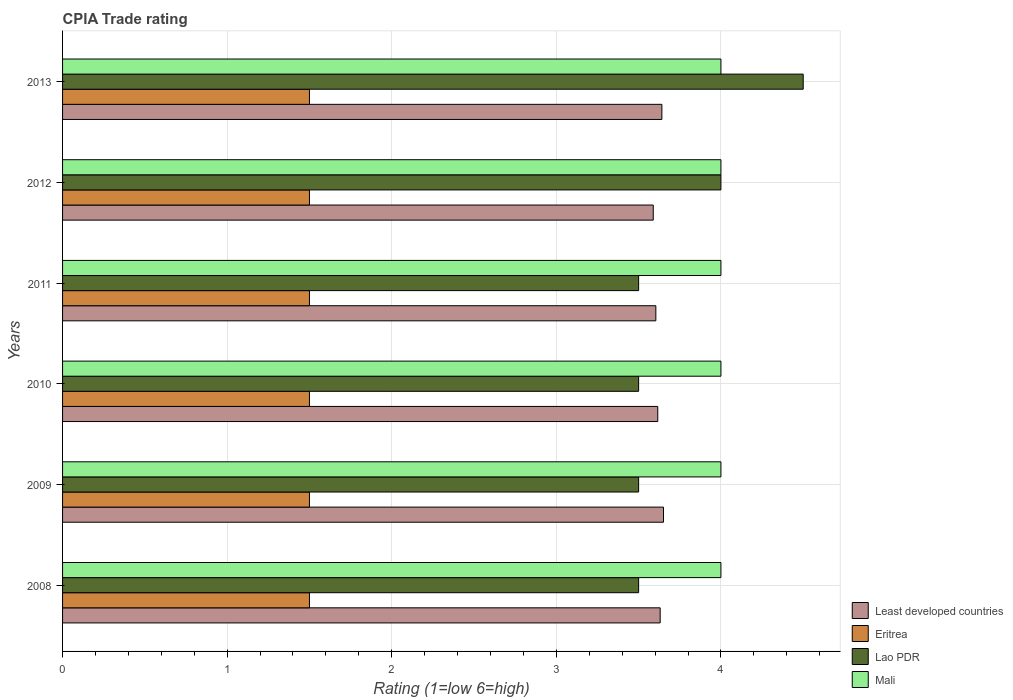How many different coloured bars are there?
Ensure brevity in your answer.  4. How many bars are there on the 1st tick from the top?
Ensure brevity in your answer.  4. How many bars are there on the 5th tick from the bottom?
Provide a succinct answer. 4. What is the label of the 4th group of bars from the top?
Your answer should be compact. 2010. In how many cases, is the number of bars for a given year not equal to the number of legend labels?
Your answer should be very brief. 0. What is the CPIA rating in Lao PDR in 2010?
Make the answer very short. 3.5. Across all years, what is the maximum CPIA rating in Least developed countries?
Give a very brief answer. 3.65. Across all years, what is the minimum CPIA rating in Mali?
Offer a terse response. 4. In which year was the CPIA rating in Least developed countries maximum?
Offer a terse response. 2009. In which year was the CPIA rating in Mali minimum?
Make the answer very short. 2008. What is the total CPIA rating in Lao PDR in the graph?
Your answer should be compact. 22.5. What is the difference between the CPIA rating in Mali in 2008 and the CPIA rating in Least developed countries in 2013?
Offer a terse response. 0.36. In the year 2013, what is the difference between the CPIA rating in Mali and CPIA rating in Eritrea?
Your answer should be compact. 2.5. What is the ratio of the CPIA rating in Mali in 2010 to that in 2012?
Make the answer very short. 1. Is the difference between the CPIA rating in Mali in 2010 and 2012 greater than the difference between the CPIA rating in Eritrea in 2010 and 2012?
Offer a terse response. No. What is the difference between the highest and the second highest CPIA rating in Mali?
Provide a short and direct response. 0. What is the difference between the highest and the lowest CPIA rating in Least developed countries?
Your answer should be compact. 0.06. What does the 1st bar from the top in 2009 represents?
Ensure brevity in your answer.  Mali. What does the 2nd bar from the bottom in 2010 represents?
Give a very brief answer. Eritrea. Is it the case that in every year, the sum of the CPIA rating in Mali and CPIA rating in Least developed countries is greater than the CPIA rating in Lao PDR?
Keep it short and to the point. Yes. Are the values on the major ticks of X-axis written in scientific E-notation?
Offer a terse response. No. Does the graph contain grids?
Keep it short and to the point. Yes. Where does the legend appear in the graph?
Your answer should be very brief. Bottom right. How many legend labels are there?
Give a very brief answer. 4. How are the legend labels stacked?
Your answer should be very brief. Vertical. What is the title of the graph?
Provide a succinct answer. CPIA Trade rating. What is the label or title of the Y-axis?
Your answer should be compact. Years. What is the Rating (1=low 6=high) of Least developed countries in 2008?
Offer a very short reply. 3.63. What is the Rating (1=low 6=high) of Eritrea in 2008?
Make the answer very short. 1.5. What is the Rating (1=low 6=high) of Least developed countries in 2009?
Give a very brief answer. 3.65. What is the Rating (1=low 6=high) of Lao PDR in 2009?
Provide a short and direct response. 3.5. What is the Rating (1=low 6=high) of Mali in 2009?
Your answer should be compact. 4. What is the Rating (1=low 6=high) in Least developed countries in 2010?
Provide a short and direct response. 3.62. What is the Rating (1=low 6=high) of Eritrea in 2010?
Give a very brief answer. 1.5. What is the Rating (1=low 6=high) of Mali in 2010?
Your answer should be compact. 4. What is the Rating (1=low 6=high) in Least developed countries in 2011?
Provide a short and direct response. 3.6. What is the Rating (1=low 6=high) in Eritrea in 2011?
Your answer should be compact. 1.5. What is the Rating (1=low 6=high) of Lao PDR in 2011?
Offer a terse response. 3.5. What is the Rating (1=low 6=high) in Mali in 2011?
Provide a succinct answer. 4. What is the Rating (1=low 6=high) of Least developed countries in 2012?
Provide a succinct answer. 3.59. What is the Rating (1=low 6=high) in Lao PDR in 2012?
Your answer should be very brief. 4. What is the Rating (1=low 6=high) of Least developed countries in 2013?
Keep it short and to the point. 3.64. What is the Rating (1=low 6=high) of Mali in 2013?
Your answer should be compact. 4. Across all years, what is the maximum Rating (1=low 6=high) in Least developed countries?
Offer a very short reply. 3.65. Across all years, what is the maximum Rating (1=low 6=high) in Eritrea?
Give a very brief answer. 1.5. Across all years, what is the minimum Rating (1=low 6=high) of Least developed countries?
Your answer should be very brief. 3.59. Across all years, what is the minimum Rating (1=low 6=high) of Lao PDR?
Keep it short and to the point. 3.5. Across all years, what is the minimum Rating (1=low 6=high) in Mali?
Ensure brevity in your answer.  4. What is the total Rating (1=low 6=high) in Least developed countries in the graph?
Provide a short and direct response. 21.73. What is the total Rating (1=low 6=high) of Mali in the graph?
Your answer should be very brief. 24. What is the difference between the Rating (1=low 6=high) in Least developed countries in 2008 and that in 2009?
Offer a terse response. -0.02. What is the difference between the Rating (1=low 6=high) in Eritrea in 2008 and that in 2009?
Your answer should be compact. 0. What is the difference between the Rating (1=low 6=high) of Mali in 2008 and that in 2009?
Provide a succinct answer. 0. What is the difference between the Rating (1=low 6=high) in Least developed countries in 2008 and that in 2010?
Your answer should be compact. 0.01. What is the difference between the Rating (1=low 6=high) of Eritrea in 2008 and that in 2010?
Your response must be concise. 0. What is the difference between the Rating (1=low 6=high) in Least developed countries in 2008 and that in 2011?
Provide a succinct answer. 0.03. What is the difference between the Rating (1=low 6=high) in Lao PDR in 2008 and that in 2011?
Make the answer very short. 0. What is the difference between the Rating (1=low 6=high) in Mali in 2008 and that in 2011?
Keep it short and to the point. 0. What is the difference between the Rating (1=low 6=high) of Least developed countries in 2008 and that in 2012?
Your response must be concise. 0.04. What is the difference between the Rating (1=low 6=high) in Least developed countries in 2008 and that in 2013?
Ensure brevity in your answer.  -0.01. What is the difference between the Rating (1=low 6=high) of Lao PDR in 2008 and that in 2013?
Provide a succinct answer. -1. What is the difference between the Rating (1=low 6=high) in Mali in 2008 and that in 2013?
Ensure brevity in your answer.  0. What is the difference between the Rating (1=low 6=high) in Least developed countries in 2009 and that in 2010?
Provide a succinct answer. 0.03. What is the difference between the Rating (1=low 6=high) in Eritrea in 2009 and that in 2010?
Make the answer very short. 0. What is the difference between the Rating (1=low 6=high) in Mali in 2009 and that in 2010?
Offer a very short reply. 0. What is the difference between the Rating (1=low 6=high) in Least developed countries in 2009 and that in 2011?
Make the answer very short. 0.05. What is the difference between the Rating (1=low 6=high) of Eritrea in 2009 and that in 2011?
Your answer should be very brief. 0. What is the difference between the Rating (1=low 6=high) of Lao PDR in 2009 and that in 2011?
Your answer should be very brief. 0. What is the difference between the Rating (1=low 6=high) in Mali in 2009 and that in 2011?
Give a very brief answer. 0. What is the difference between the Rating (1=low 6=high) in Least developed countries in 2009 and that in 2012?
Ensure brevity in your answer.  0.06. What is the difference between the Rating (1=low 6=high) of Lao PDR in 2009 and that in 2012?
Your answer should be very brief. -0.5. What is the difference between the Rating (1=low 6=high) in Mali in 2009 and that in 2012?
Your answer should be very brief. 0. What is the difference between the Rating (1=low 6=high) of Least developed countries in 2009 and that in 2013?
Provide a succinct answer. 0.01. What is the difference between the Rating (1=low 6=high) of Eritrea in 2009 and that in 2013?
Provide a short and direct response. 0. What is the difference between the Rating (1=low 6=high) in Lao PDR in 2009 and that in 2013?
Keep it short and to the point. -1. What is the difference between the Rating (1=low 6=high) in Mali in 2009 and that in 2013?
Provide a succinct answer. 0. What is the difference between the Rating (1=low 6=high) of Least developed countries in 2010 and that in 2011?
Make the answer very short. 0.01. What is the difference between the Rating (1=low 6=high) of Lao PDR in 2010 and that in 2011?
Keep it short and to the point. 0. What is the difference between the Rating (1=low 6=high) in Least developed countries in 2010 and that in 2012?
Your answer should be compact. 0.03. What is the difference between the Rating (1=low 6=high) in Lao PDR in 2010 and that in 2012?
Ensure brevity in your answer.  -0.5. What is the difference between the Rating (1=low 6=high) of Mali in 2010 and that in 2012?
Offer a terse response. 0. What is the difference between the Rating (1=low 6=high) in Least developed countries in 2010 and that in 2013?
Offer a very short reply. -0.03. What is the difference between the Rating (1=low 6=high) of Eritrea in 2010 and that in 2013?
Offer a terse response. 0. What is the difference between the Rating (1=low 6=high) of Lao PDR in 2010 and that in 2013?
Provide a succinct answer. -1. What is the difference between the Rating (1=low 6=high) in Mali in 2010 and that in 2013?
Provide a short and direct response. 0. What is the difference between the Rating (1=low 6=high) of Least developed countries in 2011 and that in 2012?
Make the answer very short. 0.02. What is the difference between the Rating (1=low 6=high) of Eritrea in 2011 and that in 2012?
Provide a short and direct response. 0. What is the difference between the Rating (1=low 6=high) of Lao PDR in 2011 and that in 2012?
Make the answer very short. -0.5. What is the difference between the Rating (1=low 6=high) in Mali in 2011 and that in 2012?
Offer a terse response. 0. What is the difference between the Rating (1=low 6=high) in Least developed countries in 2011 and that in 2013?
Your answer should be compact. -0.04. What is the difference between the Rating (1=low 6=high) in Eritrea in 2011 and that in 2013?
Your answer should be compact. 0. What is the difference between the Rating (1=low 6=high) in Mali in 2011 and that in 2013?
Make the answer very short. 0. What is the difference between the Rating (1=low 6=high) in Least developed countries in 2012 and that in 2013?
Give a very brief answer. -0.05. What is the difference between the Rating (1=low 6=high) in Least developed countries in 2008 and the Rating (1=low 6=high) in Eritrea in 2009?
Keep it short and to the point. 2.13. What is the difference between the Rating (1=low 6=high) in Least developed countries in 2008 and the Rating (1=low 6=high) in Lao PDR in 2009?
Your response must be concise. 0.13. What is the difference between the Rating (1=low 6=high) in Least developed countries in 2008 and the Rating (1=low 6=high) in Mali in 2009?
Provide a succinct answer. -0.37. What is the difference between the Rating (1=low 6=high) in Eritrea in 2008 and the Rating (1=low 6=high) in Lao PDR in 2009?
Make the answer very short. -2. What is the difference between the Rating (1=low 6=high) in Lao PDR in 2008 and the Rating (1=low 6=high) in Mali in 2009?
Give a very brief answer. -0.5. What is the difference between the Rating (1=low 6=high) of Least developed countries in 2008 and the Rating (1=low 6=high) of Eritrea in 2010?
Your response must be concise. 2.13. What is the difference between the Rating (1=low 6=high) of Least developed countries in 2008 and the Rating (1=low 6=high) of Lao PDR in 2010?
Your response must be concise. 0.13. What is the difference between the Rating (1=low 6=high) of Least developed countries in 2008 and the Rating (1=low 6=high) of Mali in 2010?
Offer a very short reply. -0.37. What is the difference between the Rating (1=low 6=high) in Eritrea in 2008 and the Rating (1=low 6=high) in Lao PDR in 2010?
Make the answer very short. -2. What is the difference between the Rating (1=low 6=high) of Eritrea in 2008 and the Rating (1=low 6=high) of Mali in 2010?
Offer a terse response. -2.5. What is the difference between the Rating (1=low 6=high) in Lao PDR in 2008 and the Rating (1=low 6=high) in Mali in 2010?
Offer a very short reply. -0.5. What is the difference between the Rating (1=low 6=high) of Least developed countries in 2008 and the Rating (1=low 6=high) of Eritrea in 2011?
Offer a very short reply. 2.13. What is the difference between the Rating (1=low 6=high) of Least developed countries in 2008 and the Rating (1=low 6=high) of Lao PDR in 2011?
Your response must be concise. 0.13. What is the difference between the Rating (1=low 6=high) in Least developed countries in 2008 and the Rating (1=low 6=high) in Mali in 2011?
Make the answer very short. -0.37. What is the difference between the Rating (1=low 6=high) of Eritrea in 2008 and the Rating (1=low 6=high) of Lao PDR in 2011?
Give a very brief answer. -2. What is the difference between the Rating (1=low 6=high) of Least developed countries in 2008 and the Rating (1=low 6=high) of Eritrea in 2012?
Offer a terse response. 2.13. What is the difference between the Rating (1=low 6=high) in Least developed countries in 2008 and the Rating (1=low 6=high) in Lao PDR in 2012?
Ensure brevity in your answer.  -0.37. What is the difference between the Rating (1=low 6=high) of Least developed countries in 2008 and the Rating (1=low 6=high) of Mali in 2012?
Offer a terse response. -0.37. What is the difference between the Rating (1=low 6=high) of Least developed countries in 2008 and the Rating (1=low 6=high) of Eritrea in 2013?
Offer a terse response. 2.13. What is the difference between the Rating (1=low 6=high) of Least developed countries in 2008 and the Rating (1=low 6=high) of Lao PDR in 2013?
Make the answer very short. -0.87. What is the difference between the Rating (1=low 6=high) of Least developed countries in 2008 and the Rating (1=low 6=high) of Mali in 2013?
Give a very brief answer. -0.37. What is the difference between the Rating (1=low 6=high) in Eritrea in 2008 and the Rating (1=low 6=high) in Mali in 2013?
Provide a succinct answer. -2.5. What is the difference between the Rating (1=low 6=high) of Lao PDR in 2008 and the Rating (1=low 6=high) of Mali in 2013?
Provide a succinct answer. -0.5. What is the difference between the Rating (1=low 6=high) of Least developed countries in 2009 and the Rating (1=low 6=high) of Eritrea in 2010?
Provide a short and direct response. 2.15. What is the difference between the Rating (1=low 6=high) in Least developed countries in 2009 and the Rating (1=low 6=high) in Lao PDR in 2010?
Keep it short and to the point. 0.15. What is the difference between the Rating (1=low 6=high) in Least developed countries in 2009 and the Rating (1=low 6=high) in Mali in 2010?
Provide a succinct answer. -0.35. What is the difference between the Rating (1=low 6=high) in Eritrea in 2009 and the Rating (1=low 6=high) in Mali in 2010?
Your answer should be compact. -2.5. What is the difference between the Rating (1=low 6=high) in Lao PDR in 2009 and the Rating (1=low 6=high) in Mali in 2010?
Provide a succinct answer. -0.5. What is the difference between the Rating (1=low 6=high) of Least developed countries in 2009 and the Rating (1=low 6=high) of Eritrea in 2011?
Keep it short and to the point. 2.15. What is the difference between the Rating (1=low 6=high) of Least developed countries in 2009 and the Rating (1=low 6=high) of Lao PDR in 2011?
Make the answer very short. 0.15. What is the difference between the Rating (1=low 6=high) in Least developed countries in 2009 and the Rating (1=low 6=high) in Mali in 2011?
Make the answer very short. -0.35. What is the difference between the Rating (1=low 6=high) of Least developed countries in 2009 and the Rating (1=low 6=high) of Eritrea in 2012?
Ensure brevity in your answer.  2.15. What is the difference between the Rating (1=low 6=high) in Least developed countries in 2009 and the Rating (1=low 6=high) in Lao PDR in 2012?
Your answer should be compact. -0.35. What is the difference between the Rating (1=low 6=high) of Least developed countries in 2009 and the Rating (1=low 6=high) of Mali in 2012?
Keep it short and to the point. -0.35. What is the difference between the Rating (1=low 6=high) of Eritrea in 2009 and the Rating (1=low 6=high) of Lao PDR in 2012?
Provide a short and direct response. -2.5. What is the difference between the Rating (1=low 6=high) of Lao PDR in 2009 and the Rating (1=low 6=high) of Mali in 2012?
Offer a terse response. -0.5. What is the difference between the Rating (1=low 6=high) of Least developed countries in 2009 and the Rating (1=low 6=high) of Eritrea in 2013?
Ensure brevity in your answer.  2.15. What is the difference between the Rating (1=low 6=high) in Least developed countries in 2009 and the Rating (1=low 6=high) in Lao PDR in 2013?
Make the answer very short. -0.85. What is the difference between the Rating (1=low 6=high) in Least developed countries in 2009 and the Rating (1=low 6=high) in Mali in 2013?
Your answer should be very brief. -0.35. What is the difference between the Rating (1=low 6=high) in Eritrea in 2009 and the Rating (1=low 6=high) in Lao PDR in 2013?
Make the answer very short. -3. What is the difference between the Rating (1=low 6=high) of Lao PDR in 2009 and the Rating (1=low 6=high) of Mali in 2013?
Offer a very short reply. -0.5. What is the difference between the Rating (1=low 6=high) of Least developed countries in 2010 and the Rating (1=low 6=high) of Eritrea in 2011?
Offer a very short reply. 2.12. What is the difference between the Rating (1=low 6=high) of Least developed countries in 2010 and the Rating (1=low 6=high) of Lao PDR in 2011?
Provide a succinct answer. 0.12. What is the difference between the Rating (1=low 6=high) in Least developed countries in 2010 and the Rating (1=low 6=high) in Mali in 2011?
Offer a terse response. -0.38. What is the difference between the Rating (1=low 6=high) of Eritrea in 2010 and the Rating (1=low 6=high) of Mali in 2011?
Make the answer very short. -2.5. What is the difference between the Rating (1=low 6=high) of Least developed countries in 2010 and the Rating (1=low 6=high) of Eritrea in 2012?
Your answer should be compact. 2.12. What is the difference between the Rating (1=low 6=high) of Least developed countries in 2010 and the Rating (1=low 6=high) of Lao PDR in 2012?
Keep it short and to the point. -0.38. What is the difference between the Rating (1=low 6=high) of Least developed countries in 2010 and the Rating (1=low 6=high) of Mali in 2012?
Offer a very short reply. -0.38. What is the difference between the Rating (1=low 6=high) of Eritrea in 2010 and the Rating (1=low 6=high) of Mali in 2012?
Provide a short and direct response. -2.5. What is the difference between the Rating (1=low 6=high) of Least developed countries in 2010 and the Rating (1=low 6=high) of Eritrea in 2013?
Your response must be concise. 2.12. What is the difference between the Rating (1=low 6=high) of Least developed countries in 2010 and the Rating (1=low 6=high) of Lao PDR in 2013?
Keep it short and to the point. -0.88. What is the difference between the Rating (1=low 6=high) in Least developed countries in 2010 and the Rating (1=low 6=high) in Mali in 2013?
Offer a terse response. -0.38. What is the difference between the Rating (1=low 6=high) of Eritrea in 2010 and the Rating (1=low 6=high) of Mali in 2013?
Your response must be concise. -2.5. What is the difference between the Rating (1=low 6=high) in Least developed countries in 2011 and the Rating (1=low 6=high) in Eritrea in 2012?
Make the answer very short. 2.1. What is the difference between the Rating (1=low 6=high) in Least developed countries in 2011 and the Rating (1=low 6=high) in Lao PDR in 2012?
Give a very brief answer. -0.4. What is the difference between the Rating (1=low 6=high) of Least developed countries in 2011 and the Rating (1=low 6=high) of Mali in 2012?
Offer a terse response. -0.4. What is the difference between the Rating (1=low 6=high) of Eritrea in 2011 and the Rating (1=low 6=high) of Mali in 2012?
Your response must be concise. -2.5. What is the difference between the Rating (1=low 6=high) in Least developed countries in 2011 and the Rating (1=low 6=high) in Eritrea in 2013?
Make the answer very short. 2.1. What is the difference between the Rating (1=low 6=high) in Least developed countries in 2011 and the Rating (1=low 6=high) in Lao PDR in 2013?
Offer a terse response. -0.9. What is the difference between the Rating (1=low 6=high) of Least developed countries in 2011 and the Rating (1=low 6=high) of Mali in 2013?
Your answer should be very brief. -0.4. What is the difference between the Rating (1=low 6=high) in Eritrea in 2011 and the Rating (1=low 6=high) in Lao PDR in 2013?
Offer a terse response. -3. What is the difference between the Rating (1=low 6=high) in Least developed countries in 2012 and the Rating (1=low 6=high) in Eritrea in 2013?
Offer a terse response. 2.09. What is the difference between the Rating (1=low 6=high) in Least developed countries in 2012 and the Rating (1=low 6=high) in Lao PDR in 2013?
Provide a short and direct response. -0.91. What is the difference between the Rating (1=low 6=high) in Least developed countries in 2012 and the Rating (1=low 6=high) in Mali in 2013?
Provide a short and direct response. -0.41. What is the difference between the Rating (1=low 6=high) in Eritrea in 2012 and the Rating (1=low 6=high) in Lao PDR in 2013?
Your answer should be very brief. -3. What is the average Rating (1=low 6=high) in Least developed countries per year?
Provide a succinct answer. 3.62. What is the average Rating (1=low 6=high) in Lao PDR per year?
Your answer should be compact. 3.75. In the year 2008, what is the difference between the Rating (1=low 6=high) of Least developed countries and Rating (1=low 6=high) of Eritrea?
Your response must be concise. 2.13. In the year 2008, what is the difference between the Rating (1=low 6=high) of Least developed countries and Rating (1=low 6=high) of Lao PDR?
Your response must be concise. 0.13. In the year 2008, what is the difference between the Rating (1=low 6=high) of Least developed countries and Rating (1=low 6=high) of Mali?
Make the answer very short. -0.37. In the year 2008, what is the difference between the Rating (1=low 6=high) in Lao PDR and Rating (1=low 6=high) in Mali?
Offer a very short reply. -0.5. In the year 2009, what is the difference between the Rating (1=low 6=high) in Least developed countries and Rating (1=low 6=high) in Eritrea?
Give a very brief answer. 2.15. In the year 2009, what is the difference between the Rating (1=low 6=high) of Least developed countries and Rating (1=low 6=high) of Lao PDR?
Your answer should be very brief. 0.15. In the year 2009, what is the difference between the Rating (1=low 6=high) of Least developed countries and Rating (1=low 6=high) of Mali?
Give a very brief answer. -0.35. In the year 2009, what is the difference between the Rating (1=low 6=high) in Eritrea and Rating (1=low 6=high) in Lao PDR?
Offer a terse response. -2. In the year 2009, what is the difference between the Rating (1=low 6=high) of Eritrea and Rating (1=low 6=high) of Mali?
Make the answer very short. -2.5. In the year 2010, what is the difference between the Rating (1=low 6=high) of Least developed countries and Rating (1=low 6=high) of Eritrea?
Your response must be concise. 2.12. In the year 2010, what is the difference between the Rating (1=low 6=high) of Least developed countries and Rating (1=low 6=high) of Lao PDR?
Your response must be concise. 0.12. In the year 2010, what is the difference between the Rating (1=low 6=high) of Least developed countries and Rating (1=low 6=high) of Mali?
Provide a short and direct response. -0.38. In the year 2010, what is the difference between the Rating (1=low 6=high) in Eritrea and Rating (1=low 6=high) in Mali?
Your answer should be compact. -2.5. In the year 2010, what is the difference between the Rating (1=low 6=high) of Lao PDR and Rating (1=low 6=high) of Mali?
Your answer should be compact. -0.5. In the year 2011, what is the difference between the Rating (1=low 6=high) of Least developed countries and Rating (1=low 6=high) of Eritrea?
Your answer should be compact. 2.1. In the year 2011, what is the difference between the Rating (1=low 6=high) of Least developed countries and Rating (1=low 6=high) of Lao PDR?
Ensure brevity in your answer.  0.1. In the year 2011, what is the difference between the Rating (1=low 6=high) of Least developed countries and Rating (1=low 6=high) of Mali?
Keep it short and to the point. -0.4. In the year 2011, what is the difference between the Rating (1=low 6=high) of Eritrea and Rating (1=low 6=high) of Mali?
Give a very brief answer. -2.5. In the year 2011, what is the difference between the Rating (1=low 6=high) in Lao PDR and Rating (1=low 6=high) in Mali?
Give a very brief answer. -0.5. In the year 2012, what is the difference between the Rating (1=low 6=high) of Least developed countries and Rating (1=low 6=high) of Eritrea?
Ensure brevity in your answer.  2.09. In the year 2012, what is the difference between the Rating (1=low 6=high) of Least developed countries and Rating (1=low 6=high) of Lao PDR?
Your response must be concise. -0.41. In the year 2012, what is the difference between the Rating (1=low 6=high) of Least developed countries and Rating (1=low 6=high) of Mali?
Your response must be concise. -0.41. In the year 2013, what is the difference between the Rating (1=low 6=high) of Least developed countries and Rating (1=low 6=high) of Eritrea?
Offer a very short reply. 2.14. In the year 2013, what is the difference between the Rating (1=low 6=high) in Least developed countries and Rating (1=low 6=high) in Lao PDR?
Your response must be concise. -0.86. In the year 2013, what is the difference between the Rating (1=low 6=high) of Least developed countries and Rating (1=low 6=high) of Mali?
Keep it short and to the point. -0.36. In the year 2013, what is the difference between the Rating (1=low 6=high) in Eritrea and Rating (1=low 6=high) in Lao PDR?
Ensure brevity in your answer.  -3. In the year 2013, what is the difference between the Rating (1=low 6=high) in Eritrea and Rating (1=low 6=high) in Mali?
Your answer should be very brief. -2.5. In the year 2013, what is the difference between the Rating (1=low 6=high) in Lao PDR and Rating (1=low 6=high) in Mali?
Offer a terse response. 0.5. What is the ratio of the Rating (1=low 6=high) in Least developed countries in 2008 to that in 2009?
Your response must be concise. 0.99. What is the ratio of the Rating (1=low 6=high) of Eritrea in 2008 to that in 2010?
Provide a succinct answer. 1. What is the ratio of the Rating (1=low 6=high) in Lao PDR in 2008 to that in 2010?
Provide a short and direct response. 1. What is the ratio of the Rating (1=low 6=high) of Mali in 2008 to that in 2010?
Your answer should be very brief. 1. What is the ratio of the Rating (1=low 6=high) of Least developed countries in 2008 to that in 2011?
Keep it short and to the point. 1.01. What is the ratio of the Rating (1=low 6=high) of Lao PDR in 2008 to that in 2011?
Offer a very short reply. 1. What is the ratio of the Rating (1=low 6=high) of Mali in 2008 to that in 2011?
Your answer should be compact. 1. What is the ratio of the Rating (1=low 6=high) in Least developed countries in 2008 to that in 2012?
Offer a terse response. 1.01. What is the ratio of the Rating (1=low 6=high) in Lao PDR in 2008 to that in 2012?
Your response must be concise. 0.88. What is the ratio of the Rating (1=low 6=high) of Eritrea in 2008 to that in 2013?
Provide a succinct answer. 1. What is the ratio of the Rating (1=low 6=high) in Least developed countries in 2009 to that in 2010?
Make the answer very short. 1.01. What is the ratio of the Rating (1=low 6=high) in Lao PDR in 2009 to that in 2010?
Your answer should be very brief. 1. What is the ratio of the Rating (1=low 6=high) in Least developed countries in 2009 to that in 2011?
Your response must be concise. 1.01. What is the ratio of the Rating (1=low 6=high) in Eritrea in 2009 to that in 2011?
Offer a very short reply. 1. What is the ratio of the Rating (1=low 6=high) in Mali in 2009 to that in 2011?
Provide a succinct answer. 1. What is the ratio of the Rating (1=low 6=high) in Least developed countries in 2009 to that in 2012?
Your response must be concise. 1.02. What is the ratio of the Rating (1=low 6=high) of Lao PDR in 2009 to that in 2012?
Your response must be concise. 0.88. What is the ratio of the Rating (1=low 6=high) in Least developed countries in 2009 to that in 2013?
Give a very brief answer. 1. What is the ratio of the Rating (1=low 6=high) in Eritrea in 2009 to that in 2013?
Make the answer very short. 1. What is the ratio of the Rating (1=low 6=high) in Lao PDR in 2009 to that in 2013?
Your answer should be compact. 0.78. What is the ratio of the Rating (1=low 6=high) in Mali in 2010 to that in 2011?
Offer a very short reply. 1. What is the ratio of the Rating (1=low 6=high) of Least developed countries in 2010 to that in 2012?
Ensure brevity in your answer.  1.01. What is the ratio of the Rating (1=low 6=high) of Eritrea in 2010 to that in 2012?
Your response must be concise. 1. What is the ratio of the Rating (1=low 6=high) in Lao PDR in 2010 to that in 2013?
Keep it short and to the point. 0.78. What is the ratio of the Rating (1=low 6=high) of Mali in 2010 to that in 2013?
Offer a very short reply. 1. What is the ratio of the Rating (1=low 6=high) of Least developed countries in 2011 to that in 2012?
Your answer should be compact. 1. What is the ratio of the Rating (1=low 6=high) in Mali in 2011 to that in 2012?
Keep it short and to the point. 1. What is the ratio of the Rating (1=low 6=high) in Least developed countries in 2011 to that in 2013?
Ensure brevity in your answer.  0.99. What is the ratio of the Rating (1=low 6=high) of Least developed countries in 2012 to that in 2013?
Your answer should be compact. 0.99. What is the difference between the highest and the second highest Rating (1=low 6=high) of Least developed countries?
Provide a succinct answer. 0.01. What is the difference between the highest and the second highest Rating (1=low 6=high) of Eritrea?
Your answer should be compact. 0. What is the difference between the highest and the lowest Rating (1=low 6=high) in Least developed countries?
Offer a terse response. 0.06. 